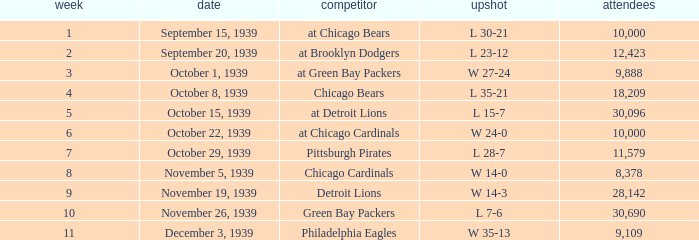Which Attendance has an Opponent of green bay packers, and a Week larger than 10? None. 